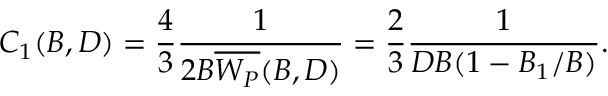Convert formula to latex. <formula><loc_0><loc_0><loc_500><loc_500>C _ { 1 } ( B , D ) = \frac { 4 } { 3 } \frac { 1 } { 2 B \overline { { W _ { P } } } ( B , D ) } = \frac { 2 } { 3 } \frac { 1 } { D B ( 1 - B _ { 1 } / B ) } .</formula> 